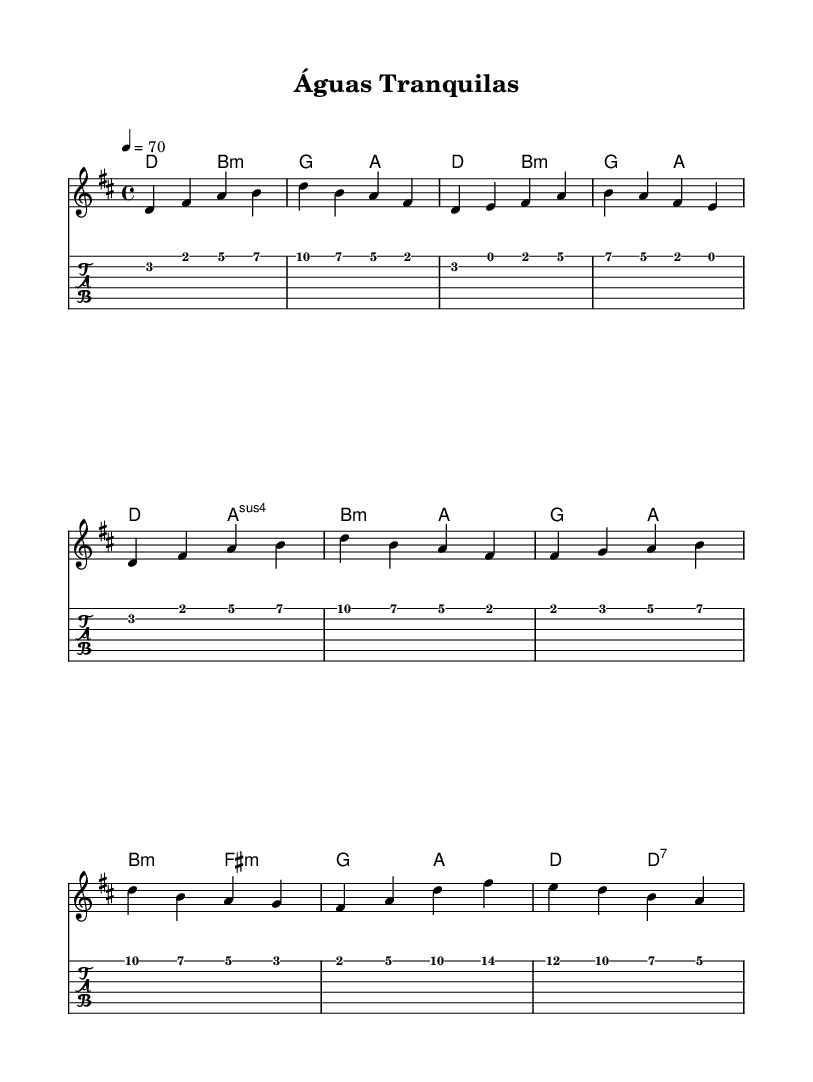What is the key signature of this music? The key signature is D major, which has two sharps (F# and C#).
Answer: D major What is the time signature of this music? The time signature is 4/4, indicating that there are four beats per measure.
Answer: 4/4 What is the tempo marking for this piece? The tempo marking is quarter note equals 70 beats per minute, indicating a moderate speed.
Answer: 70 How many measures are present in the verse section? The verse consists of two repeated phrases, making a total of four measures in this section.
Answer: Four measures Which chord appears at the beginning of the harmony? The first chord in the harmony is D major.
Answer: D major What instrument is indicated for the melody? The melody is indicated for the staff, which typically represents a treble instrument or vocal.
Answer: Treble What musical style is referenced in the title of this piece? The title "Águas Tranquilas" suggests a tranquil theme inspired by ambient Brazilian music, particularly bossa nova.
Answer: Bossa nova 